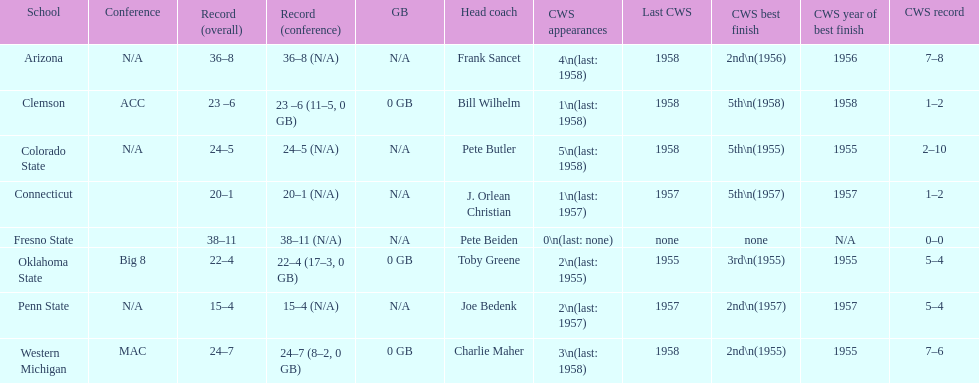List the schools that came in last place in the cws best finish. Clemson, Colorado State, Connecticut. 